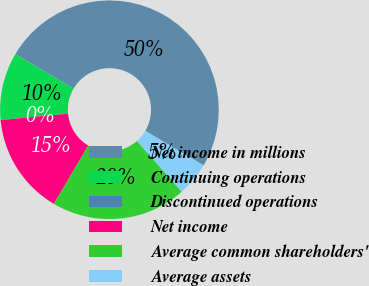Convert chart. <chart><loc_0><loc_0><loc_500><loc_500><pie_chart><fcel>Net income in millions<fcel>Continuing operations<fcel>Discontinued operations<fcel>Net income<fcel>Average common shareholders'<fcel>Average assets<nl><fcel>50.0%<fcel>10.0%<fcel>0.0%<fcel>15.0%<fcel>20.0%<fcel>5.0%<nl></chart> 